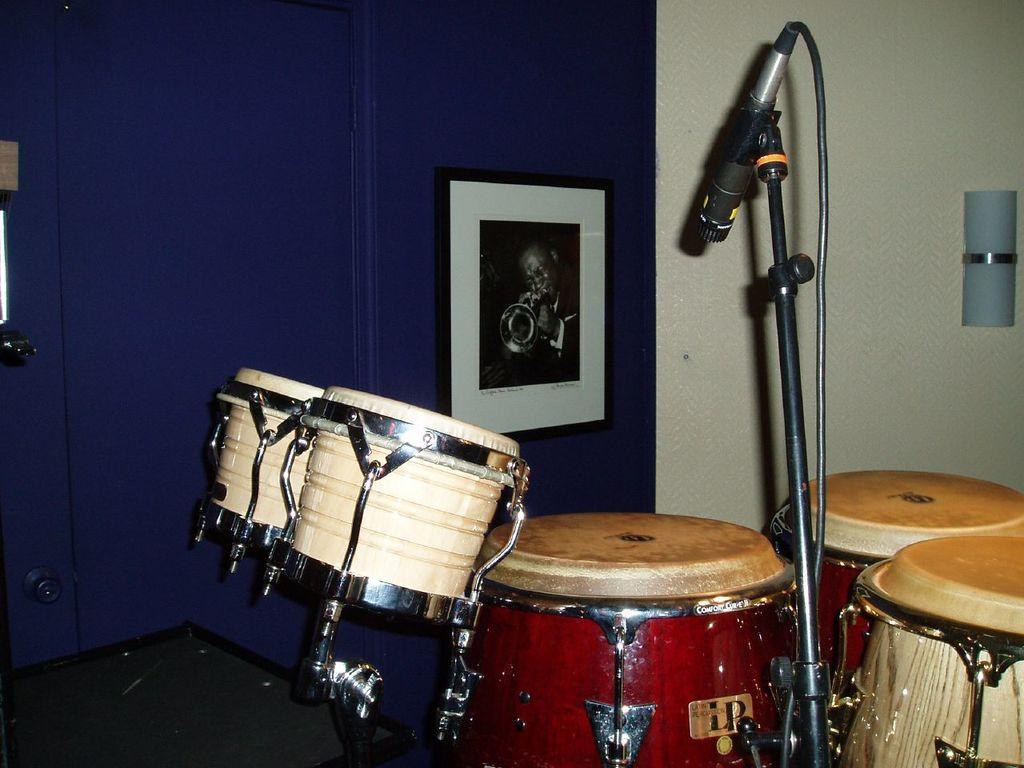What is the main object in the image? There is a microphone in the image. How is the microphone positioned in the image? The microphone is attached to a microphone stand. What other musical instruments can be seen in the image? There are musical drums in the image. What can be observed on the walls in the image? There are walls with photos and other objects attached to them in the image. How does the wall in the image express its feelings of debt? There is no mention of a wall expressing feelings or having debt in the image. The image only shows a microphone, a microphone stand, musical drums, and walls with photos and other objects attached to them. 